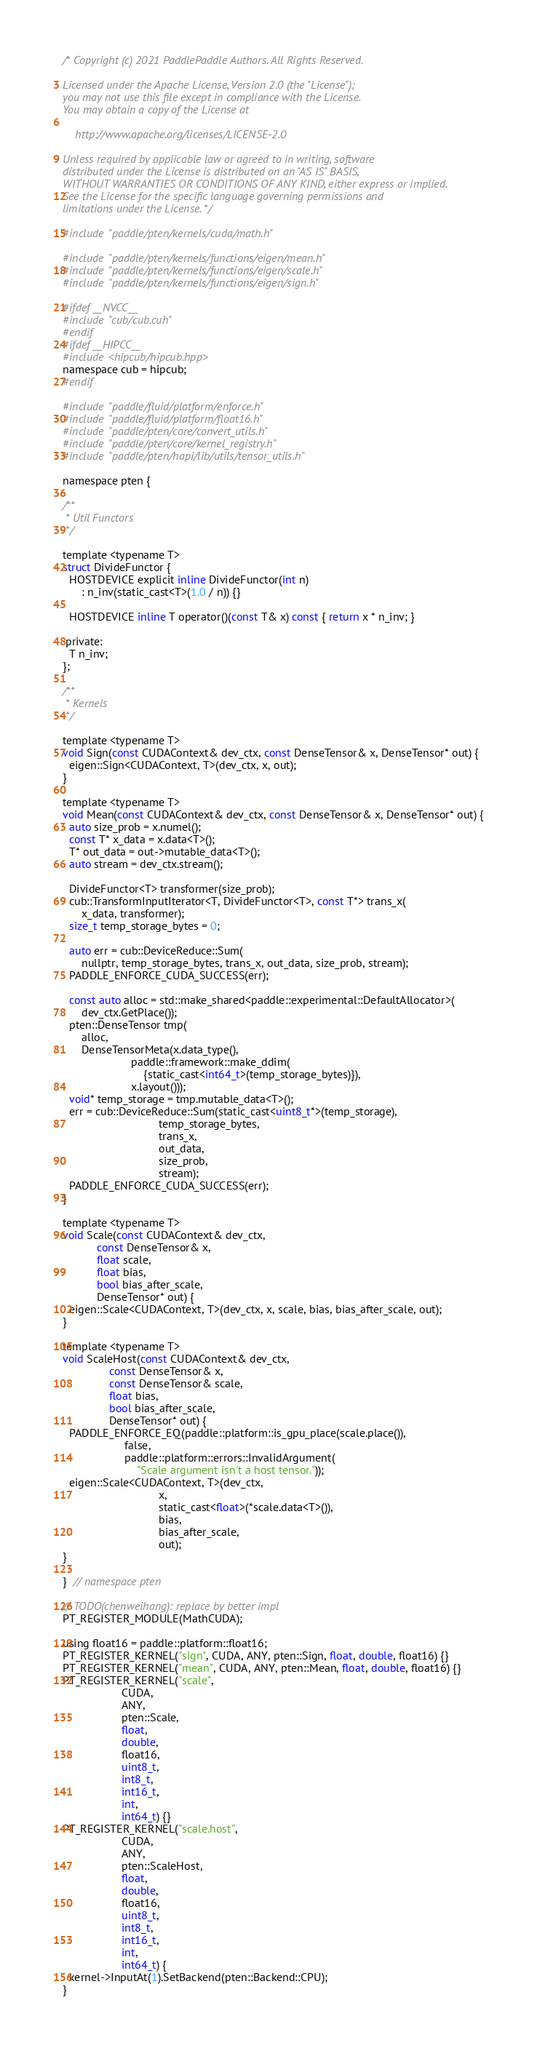Convert code to text. <code><loc_0><loc_0><loc_500><loc_500><_Cuda_>/* Copyright (c) 2021 PaddlePaddle Authors. All Rights Reserved.

Licensed under the Apache License, Version 2.0 (the "License");
you may not use this file except in compliance with the License.
You may obtain a copy of the License at

    http://www.apache.org/licenses/LICENSE-2.0

Unless required by applicable law or agreed to in writing, software
distributed under the License is distributed on an "AS IS" BASIS,
WITHOUT WARRANTIES OR CONDITIONS OF ANY KIND, either express or implied.
See the License for the specific language governing permissions and
limitations under the License. */

#include "paddle/pten/kernels/cuda/math.h"

#include "paddle/pten/kernels/functions/eigen/mean.h"
#include "paddle/pten/kernels/functions/eigen/scale.h"
#include "paddle/pten/kernels/functions/eigen/sign.h"

#ifdef __NVCC__
#include "cub/cub.cuh"
#endif
#ifdef __HIPCC__
#include <hipcub/hipcub.hpp>
namespace cub = hipcub;
#endif

#include "paddle/fluid/platform/enforce.h"
#include "paddle/fluid/platform/float16.h"
#include "paddle/pten/core/convert_utils.h"
#include "paddle/pten/core/kernel_registry.h"
#include "paddle/pten/hapi/lib/utils/tensor_utils.h"

namespace pten {

/**
 * Util Functors
 */

template <typename T>
struct DivideFunctor {
  HOSTDEVICE explicit inline DivideFunctor(int n)
      : n_inv(static_cast<T>(1.0 / n)) {}

  HOSTDEVICE inline T operator()(const T& x) const { return x * n_inv; }

 private:
  T n_inv;
};

/**
 * Kernels
 */

template <typename T>
void Sign(const CUDAContext& dev_ctx, const DenseTensor& x, DenseTensor* out) {
  eigen::Sign<CUDAContext, T>(dev_ctx, x, out);
}

template <typename T>
void Mean(const CUDAContext& dev_ctx, const DenseTensor& x, DenseTensor* out) {
  auto size_prob = x.numel();
  const T* x_data = x.data<T>();
  T* out_data = out->mutable_data<T>();
  auto stream = dev_ctx.stream();

  DivideFunctor<T> transformer(size_prob);
  cub::TransformInputIterator<T, DivideFunctor<T>, const T*> trans_x(
      x_data, transformer);
  size_t temp_storage_bytes = 0;

  auto err = cub::DeviceReduce::Sum(
      nullptr, temp_storage_bytes, trans_x, out_data, size_prob, stream);
  PADDLE_ENFORCE_CUDA_SUCCESS(err);

  const auto alloc = std::make_shared<paddle::experimental::DefaultAllocator>(
      dev_ctx.GetPlace());
  pten::DenseTensor tmp(
      alloc,
      DenseTensorMeta(x.data_type(),
                      paddle::framework::make_ddim(
                          {static_cast<int64_t>(temp_storage_bytes)}),
                      x.layout()));
  void* temp_storage = tmp.mutable_data<T>();
  err = cub::DeviceReduce::Sum(static_cast<uint8_t*>(temp_storage),
                               temp_storage_bytes,
                               trans_x,
                               out_data,
                               size_prob,
                               stream);
  PADDLE_ENFORCE_CUDA_SUCCESS(err);
}

template <typename T>
void Scale(const CUDAContext& dev_ctx,
           const DenseTensor& x,
           float scale,
           float bias,
           bool bias_after_scale,
           DenseTensor* out) {
  eigen::Scale<CUDAContext, T>(dev_ctx, x, scale, bias, bias_after_scale, out);
}

template <typename T>
void ScaleHost(const CUDAContext& dev_ctx,
               const DenseTensor& x,
               const DenseTensor& scale,
               float bias,
               bool bias_after_scale,
               DenseTensor* out) {
  PADDLE_ENFORCE_EQ(paddle::platform::is_gpu_place(scale.place()),
                    false,
                    paddle::platform::errors::InvalidArgument(
                        "Scale argument isn't a host tensor."));
  eigen::Scale<CUDAContext, T>(dev_ctx,
                               x,
                               static_cast<float>(*scale.data<T>()),
                               bias,
                               bias_after_scale,
                               out);
}

}  // namespace pten

// TODO(chenweihang): replace by better impl
PT_REGISTER_MODULE(MathCUDA);

using float16 = paddle::platform::float16;
PT_REGISTER_KERNEL("sign", CUDA, ANY, pten::Sign, float, double, float16) {}
PT_REGISTER_KERNEL("mean", CUDA, ANY, pten::Mean, float, double, float16) {}
PT_REGISTER_KERNEL("scale",
                   CUDA,
                   ANY,
                   pten::Scale,
                   float,
                   double,
                   float16,
                   uint8_t,
                   int8_t,
                   int16_t,
                   int,
                   int64_t) {}
PT_REGISTER_KERNEL("scale.host",
                   CUDA,
                   ANY,
                   pten::ScaleHost,
                   float,
                   double,
                   float16,
                   uint8_t,
                   int8_t,
                   int16_t,
                   int,
                   int64_t) {
  kernel->InputAt(1).SetBackend(pten::Backend::CPU);
}
</code> 